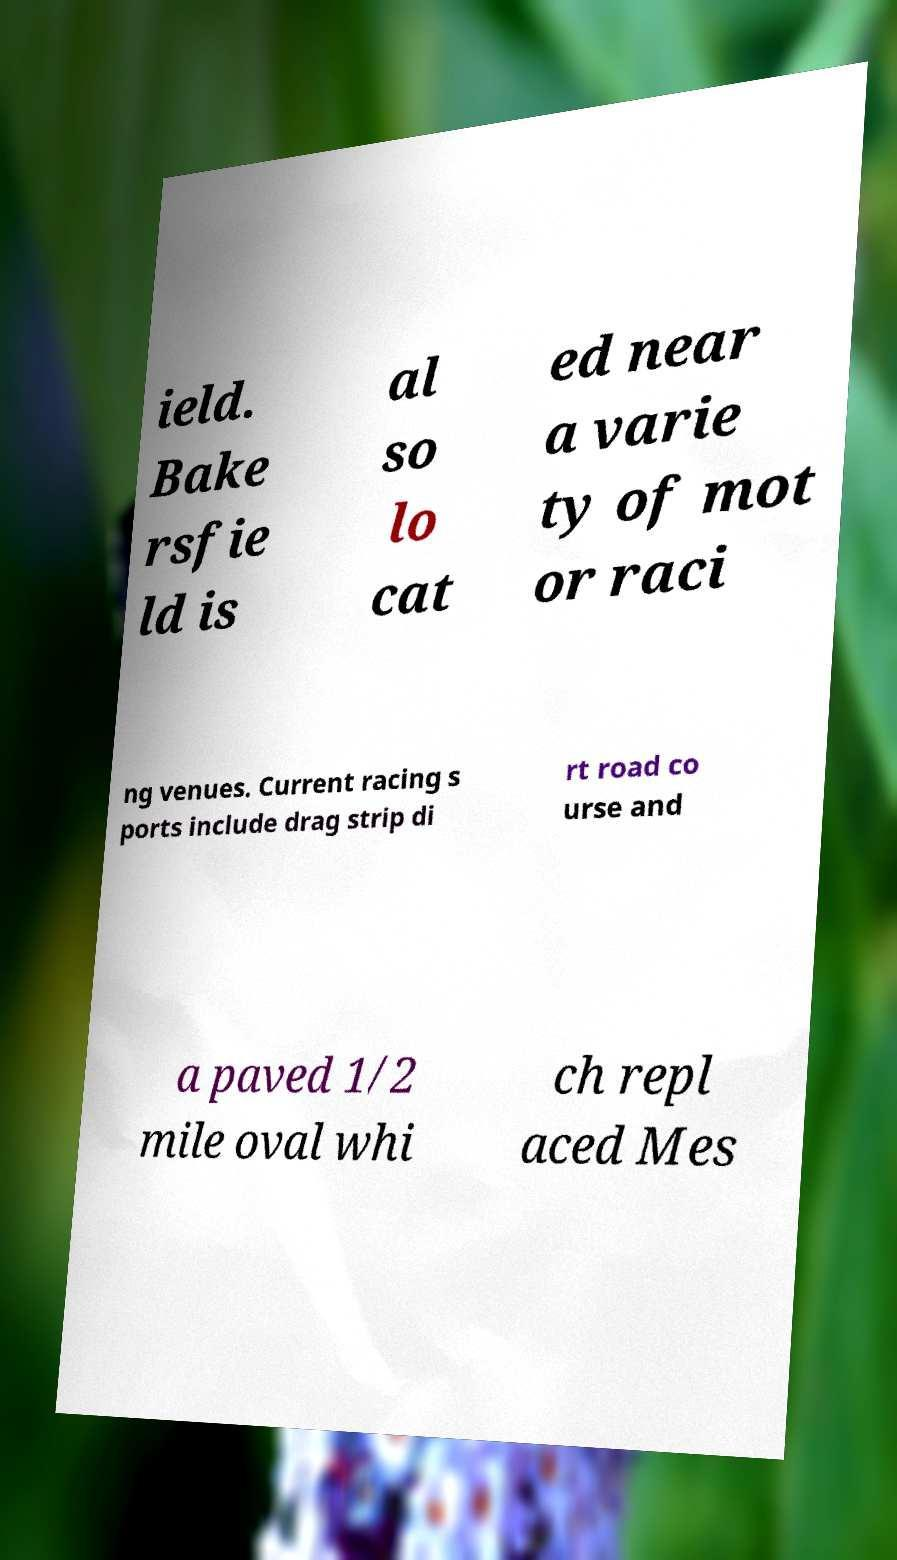Can you accurately transcribe the text from the provided image for me? ield. Bake rsfie ld is al so lo cat ed near a varie ty of mot or raci ng venues. Current racing s ports include drag strip di rt road co urse and a paved 1/2 mile oval whi ch repl aced Mes 